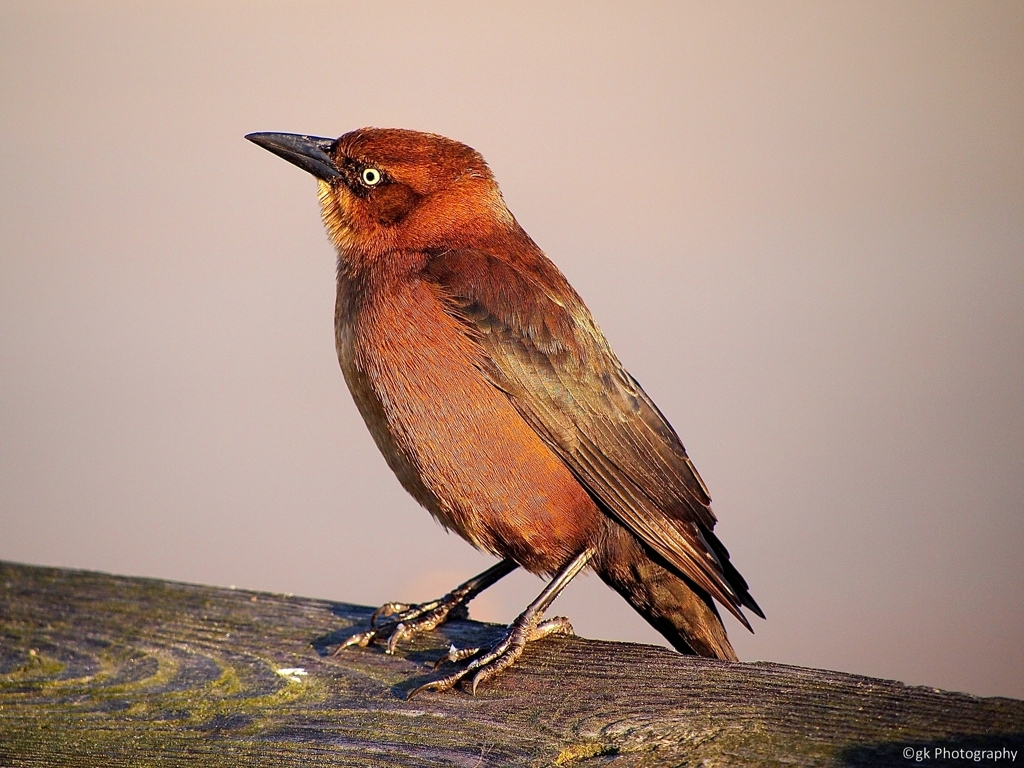Is the texture of the layers clear? Yes, the texture of the bird's feather layers is quite clear. The image allows us to see the intricacies of the feathers, including the variations in color and how they overlay each other, giving the bird a sleek appearance. 